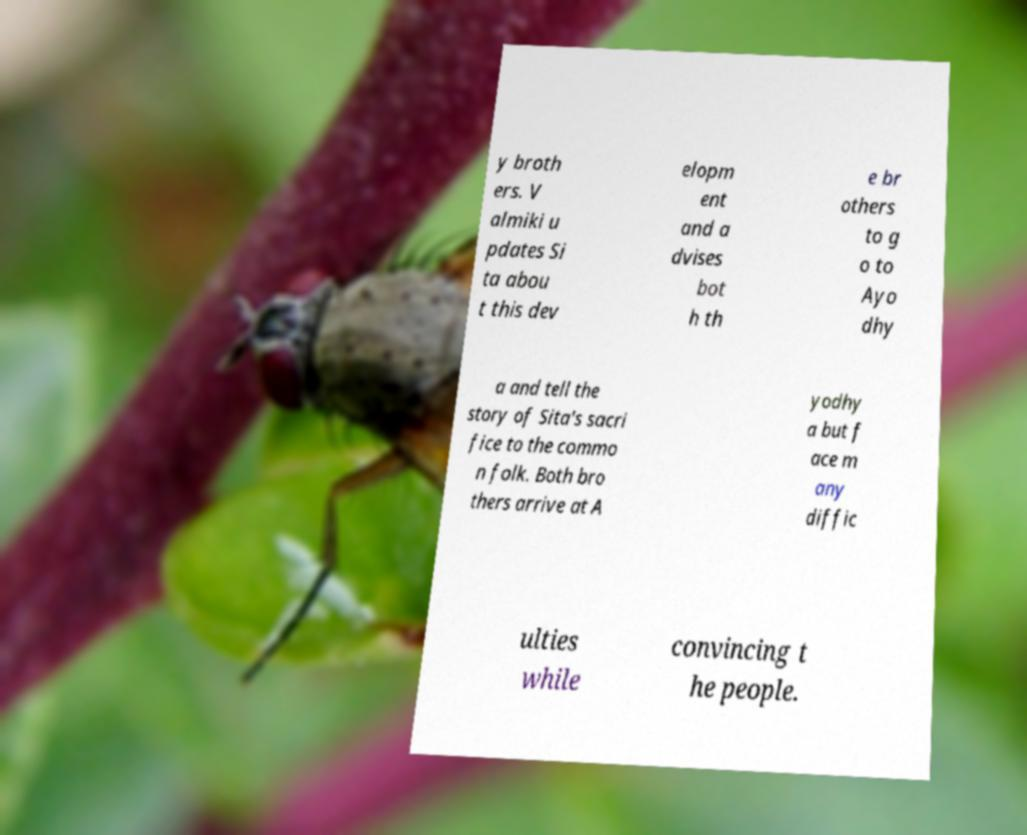What messages or text are displayed in this image? I need them in a readable, typed format. y broth ers. V almiki u pdates Si ta abou t this dev elopm ent and a dvises bot h th e br others to g o to Ayo dhy a and tell the story of Sita's sacri fice to the commo n folk. Both bro thers arrive at A yodhy a but f ace m any diffic ulties while convincing t he people. 